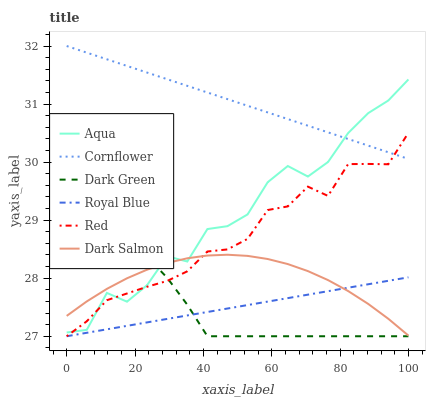Does Aqua have the minimum area under the curve?
Answer yes or no. No. Does Aqua have the maximum area under the curve?
Answer yes or no. No. Is Dark Salmon the smoothest?
Answer yes or no. No. Is Dark Salmon the roughest?
Answer yes or no. No. Does Aqua have the lowest value?
Answer yes or no. No. Does Aqua have the highest value?
Answer yes or no. No. Is Dark Green less than Cornflower?
Answer yes or no. Yes. Is Cornflower greater than Dark Salmon?
Answer yes or no. Yes. Does Dark Green intersect Cornflower?
Answer yes or no. No. 